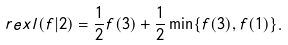<formula> <loc_0><loc_0><loc_500><loc_500>\ r e x l ( f | 2 ) = \frac { 1 } { 2 } f ( 3 ) + \frac { 1 } { 2 } \min \{ f ( 3 ) , f ( 1 ) \} .</formula> 